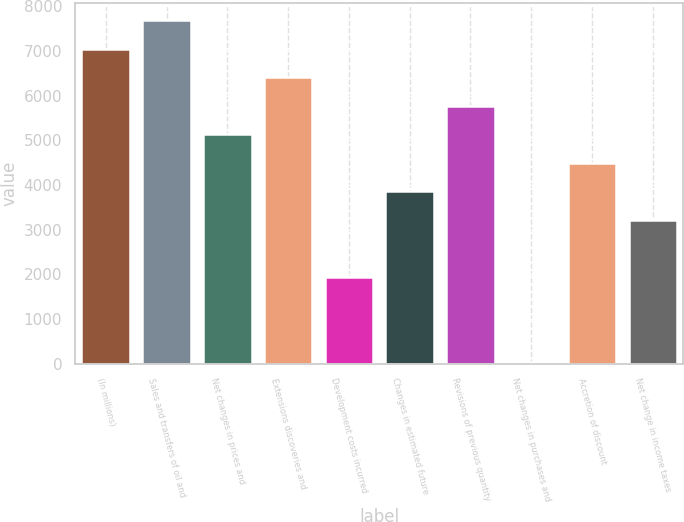Convert chart to OTSL. <chart><loc_0><loc_0><loc_500><loc_500><bar_chart><fcel>(In millions)<fcel>Sales and transfers of oil and<fcel>Net changes in prices and<fcel>Extensions discoveries and<fcel>Development costs incurred<fcel>Changes in estimated future<fcel>Revisions of previous quantity<fcel>Net changes in purchases and<fcel>Accretion of discount<fcel>Net change in income taxes<nl><fcel>7053.2<fcel>7691.4<fcel>5138.6<fcel>6415<fcel>1947.6<fcel>3862.2<fcel>5776.8<fcel>33<fcel>4500.4<fcel>3224<nl></chart> 